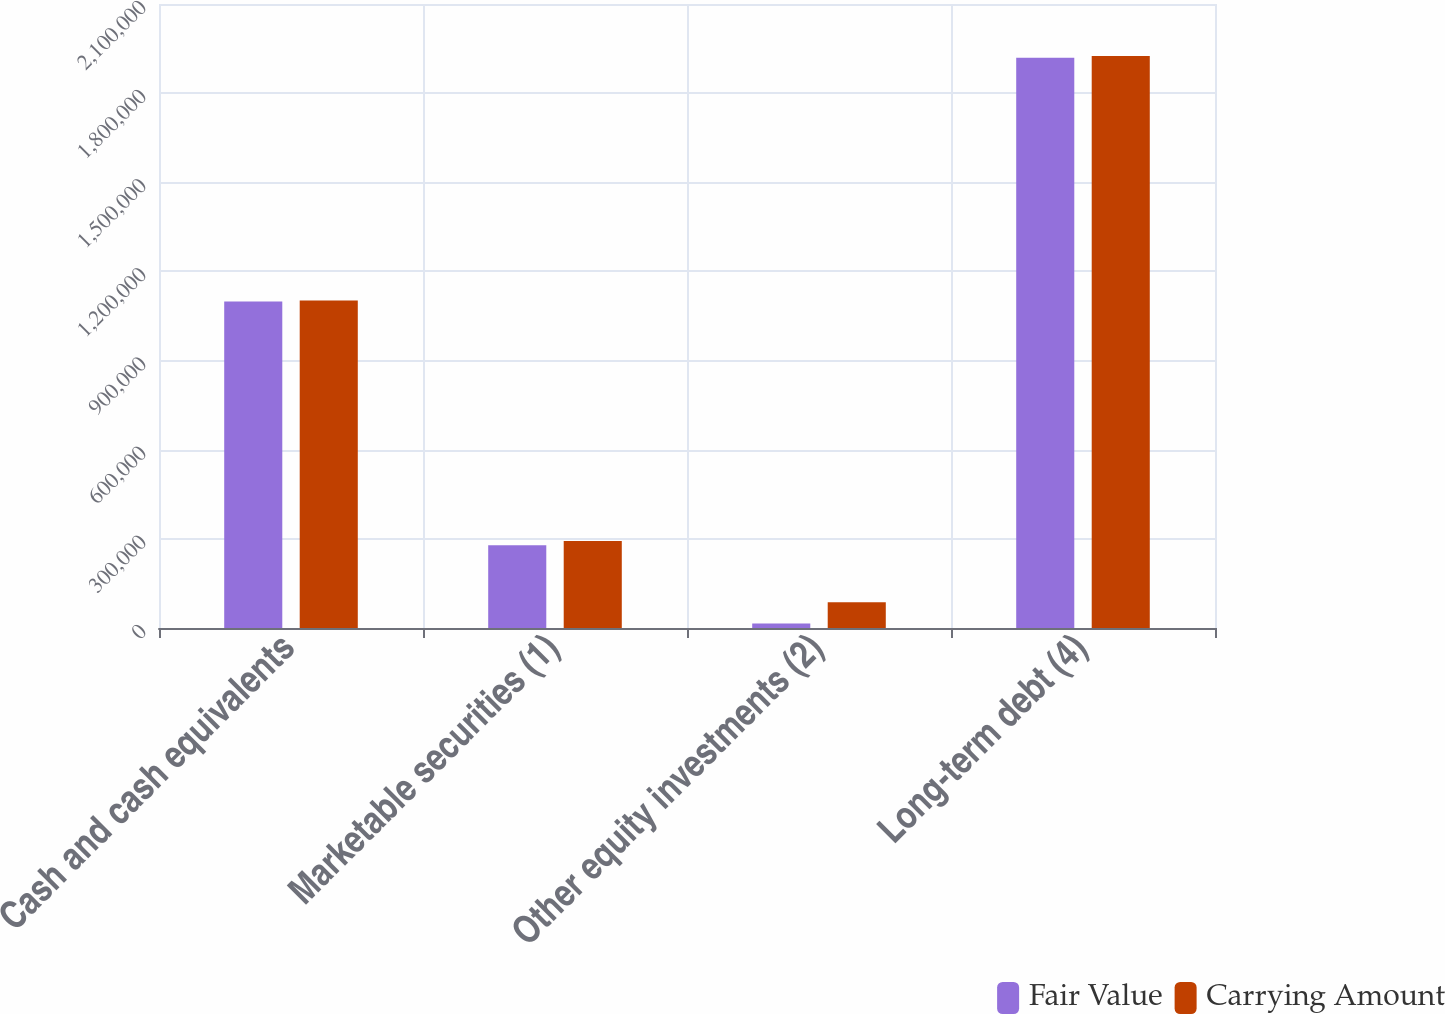Convert chart. <chart><loc_0><loc_0><loc_500><loc_500><stacked_bar_chart><ecel><fcel>Cash and cash equivalents<fcel>Marketable securities (1)<fcel>Other equity investments (2)<fcel>Long-term debt (4)<nl><fcel>Fair Value<fcel>1.09914e+06<fcel>278390<fcel>14831<fcel>1.91947e+06<nl><fcel>Carrying Amount<fcel>1.10227e+06<fcel>292550<fcel>86517<fcel>1.925e+06<nl></chart> 